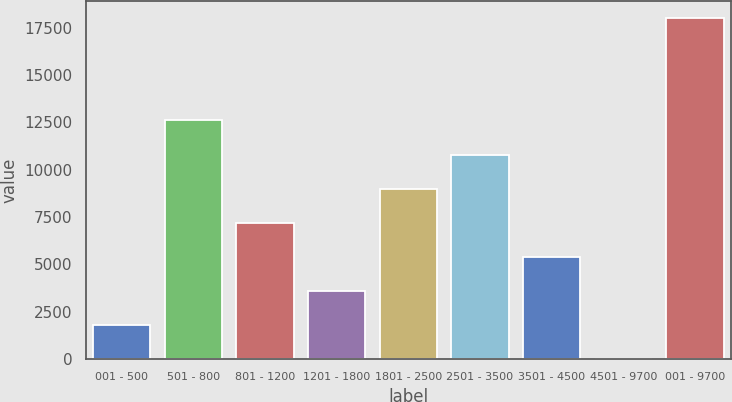Convert chart. <chart><loc_0><loc_0><loc_500><loc_500><bar_chart><fcel>001 - 500<fcel>501 - 800<fcel>801 - 1200<fcel>1201 - 1800<fcel>1801 - 2500<fcel>2501 - 3500<fcel>3501 - 4500<fcel>4501 - 9700<fcel>001 - 9700<nl><fcel>1811.8<fcel>12604.6<fcel>7208.2<fcel>3610.6<fcel>9007<fcel>10805.8<fcel>5409.4<fcel>13<fcel>18001<nl></chart> 